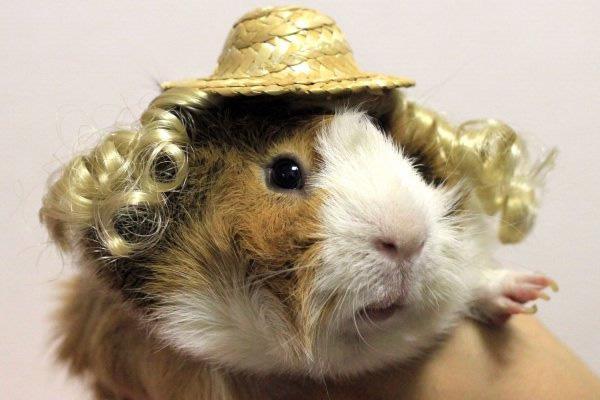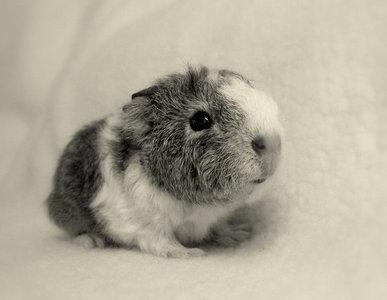The first image is the image on the left, the second image is the image on the right. Given the left and right images, does the statement "The right image shows two guinea pigs and the left shows only one, and one of the images includes a bright orange object." hold true? Answer yes or no. No. The first image is the image on the left, the second image is the image on the right. Given the left and right images, does the statement "There is at least one rodent sitting on the grass in the image on the right." hold true? Answer yes or no. No. 